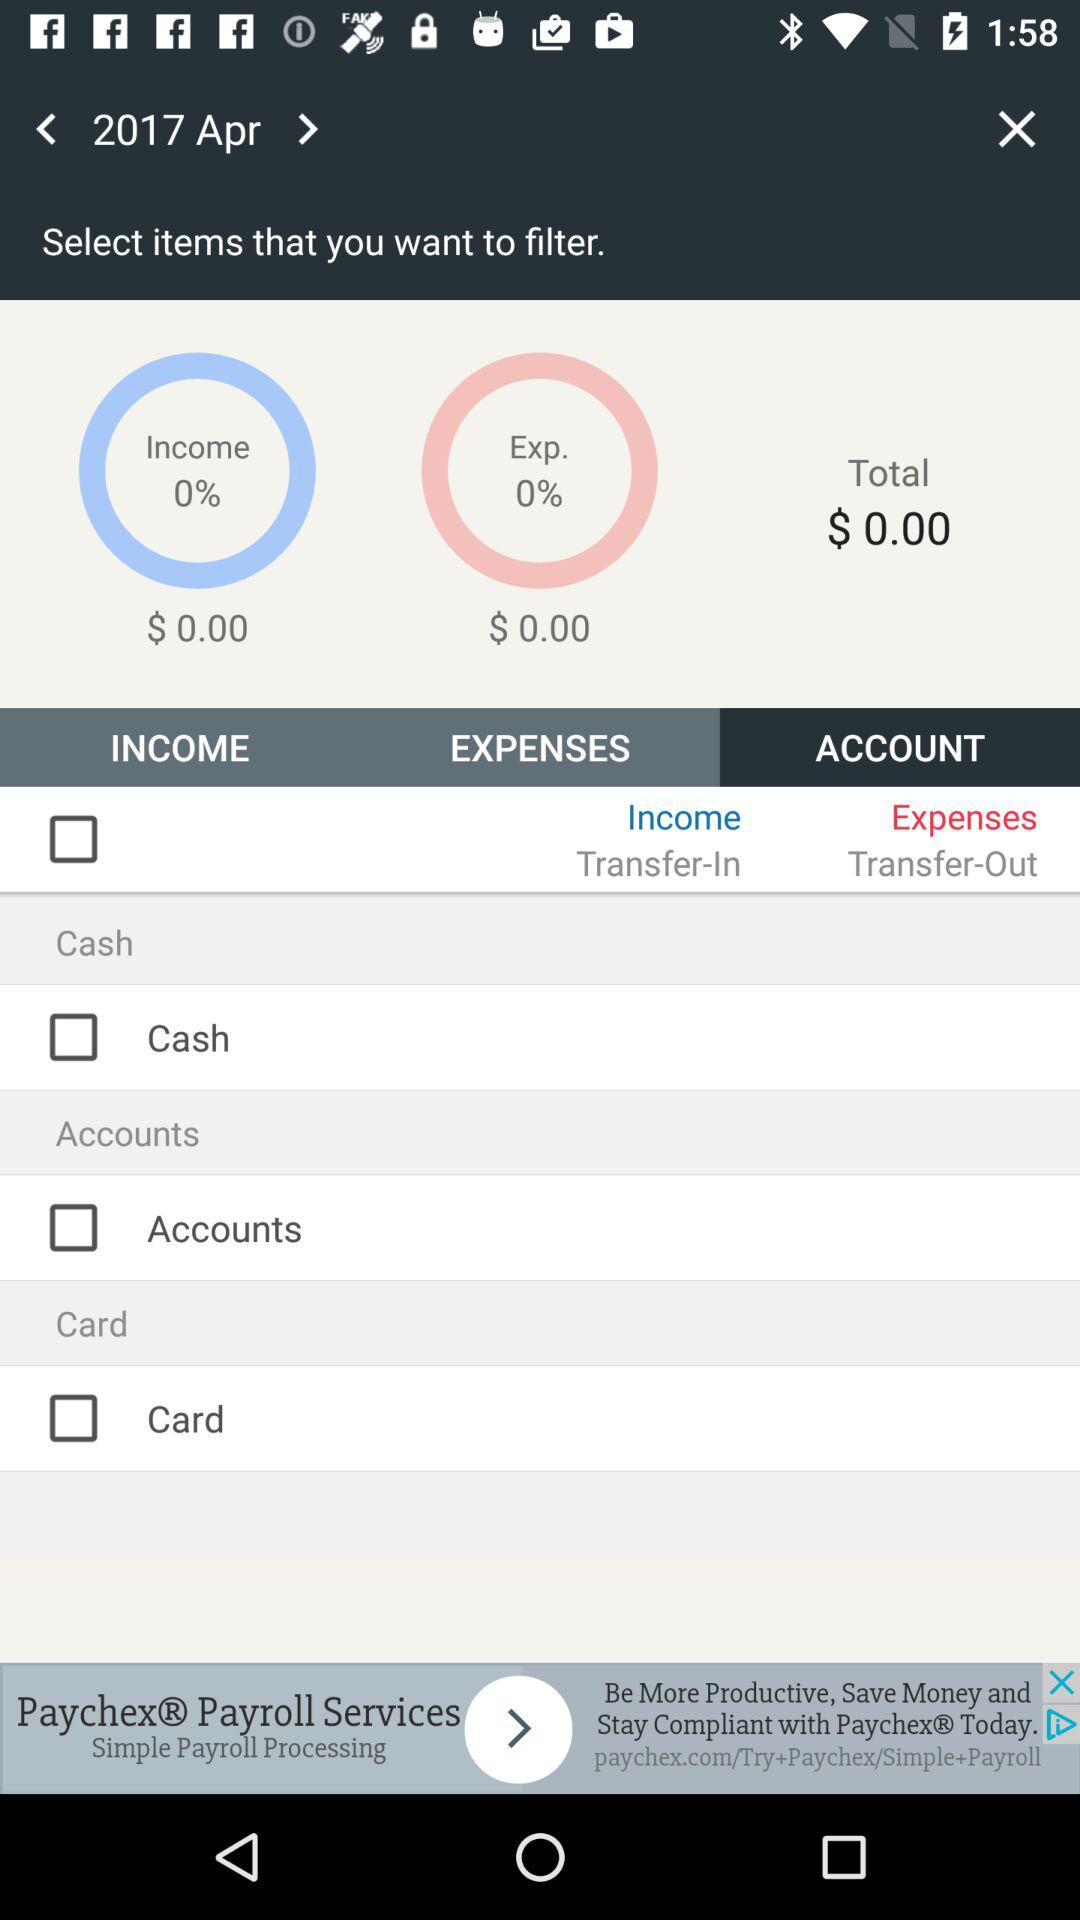What is the year and month? The year and month are 2017 and April. 